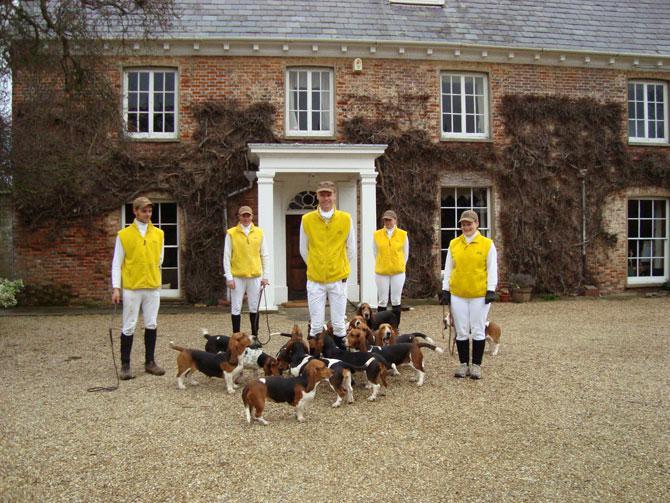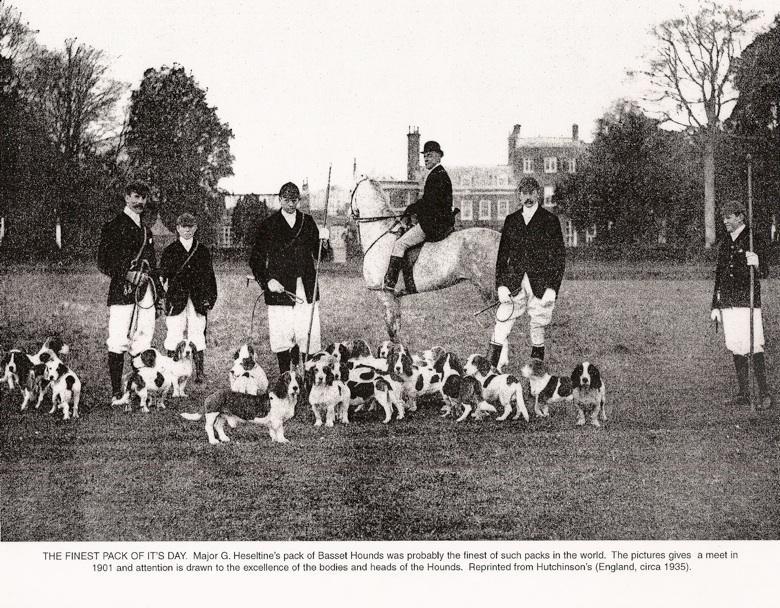The first image is the image on the left, the second image is the image on the right. Considering the images on both sides, is "A gentleman wearing a jacket, tie and beanie is walking the dogs down a road in one of the images." valid? Answer yes or no. No. The first image is the image on the left, the second image is the image on the right. Examine the images to the left and right. Is the description "There are fewer than three people wrangling a pack of dogs." accurate? Answer yes or no. No. 